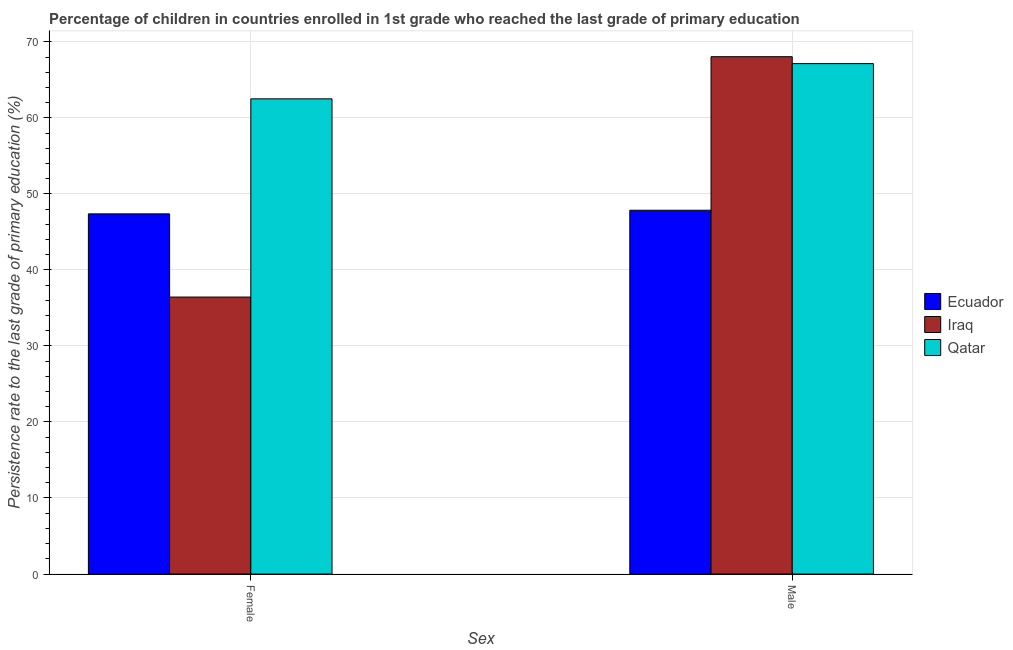How many groups of bars are there?
Give a very brief answer. 2. Are the number of bars per tick equal to the number of legend labels?
Provide a short and direct response. Yes. How many bars are there on the 2nd tick from the left?
Ensure brevity in your answer.  3. How many bars are there on the 2nd tick from the right?
Provide a succinct answer. 3. What is the label of the 1st group of bars from the left?
Offer a terse response. Female. What is the persistence rate of female students in Iraq?
Offer a very short reply. 36.43. Across all countries, what is the maximum persistence rate of female students?
Ensure brevity in your answer.  62.51. Across all countries, what is the minimum persistence rate of female students?
Offer a very short reply. 36.43. In which country was the persistence rate of male students maximum?
Your answer should be compact. Iraq. In which country was the persistence rate of male students minimum?
Offer a terse response. Ecuador. What is the total persistence rate of male students in the graph?
Ensure brevity in your answer.  183.04. What is the difference between the persistence rate of female students in Iraq and that in Qatar?
Make the answer very short. -26.07. What is the difference between the persistence rate of female students in Ecuador and the persistence rate of male students in Iraq?
Ensure brevity in your answer.  -20.68. What is the average persistence rate of female students per country?
Your response must be concise. 48.77. What is the difference between the persistence rate of male students and persistence rate of female students in Qatar?
Your answer should be compact. 4.63. In how many countries, is the persistence rate of male students greater than 24 %?
Provide a short and direct response. 3. What is the ratio of the persistence rate of female students in Qatar to that in Ecuador?
Ensure brevity in your answer.  1.32. Is the persistence rate of female students in Qatar less than that in Iraq?
Your answer should be very brief. No. In how many countries, is the persistence rate of male students greater than the average persistence rate of male students taken over all countries?
Offer a terse response. 2. What does the 2nd bar from the left in Female represents?
Give a very brief answer. Iraq. What does the 2nd bar from the right in Male represents?
Your answer should be very brief. Iraq. How many countries are there in the graph?
Your response must be concise. 3. Does the graph contain any zero values?
Keep it short and to the point. No. Does the graph contain grids?
Your answer should be compact. Yes. Where does the legend appear in the graph?
Provide a succinct answer. Center right. What is the title of the graph?
Offer a very short reply. Percentage of children in countries enrolled in 1st grade who reached the last grade of primary education. Does "Qatar" appear as one of the legend labels in the graph?
Offer a terse response. Yes. What is the label or title of the X-axis?
Your answer should be compact. Sex. What is the label or title of the Y-axis?
Provide a short and direct response. Persistence rate to the last grade of primary education (%). What is the Persistence rate to the last grade of primary education (%) in Ecuador in Female?
Give a very brief answer. 47.37. What is the Persistence rate to the last grade of primary education (%) of Iraq in Female?
Your answer should be compact. 36.43. What is the Persistence rate to the last grade of primary education (%) of Qatar in Female?
Your response must be concise. 62.51. What is the Persistence rate to the last grade of primary education (%) in Ecuador in Male?
Your answer should be very brief. 47.85. What is the Persistence rate to the last grade of primary education (%) in Iraq in Male?
Make the answer very short. 68.05. What is the Persistence rate to the last grade of primary education (%) of Qatar in Male?
Your response must be concise. 67.14. Across all Sex, what is the maximum Persistence rate to the last grade of primary education (%) in Ecuador?
Your response must be concise. 47.85. Across all Sex, what is the maximum Persistence rate to the last grade of primary education (%) of Iraq?
Your answer should be compact. 68.05. Across all Sex, what is the maximum Persistence rate to the last grade of primary education (%) of Qatar?
Your response must be concise. 67.14. Across all Sex, what is the minimum Persistence rate to the last grade of primary education (%) of Ecuador?
Your response must be concise. 47.37. Across all Sex, what is the minimum Persistence rate to the last grade of primary education (%) in Iraq?
Ensure brevity in your answer.  36.43. Across all Sex, what is the minimum Persistence rate to the last grade of primary education (%) of Qatar?
Your response must be concise. 62.51. What is the total Persistence rate to the last grade of primary education (%) in Ecuador in the graph?
Provide a short and direct response. 95.23. What is the total Persistence rate to the last grade of primary education (%) of Iraq in the graph?
Keep it short and to the point. 104.48. What is the total Persistence rate to the last grade of primary education (%) in Qatar in the graph?
Provide a succinct answer. 129.65. What is the difference between the Persistence rate to the last grade of primary education (%) in Ecuador in Female and that in Male?
Ensure brevity in your answer.  -0.48. What is the difference between the Persistence rate to the last grade of primary education (%) of Iraq in Female and that in Male?
Ensure brevity in your answer.  -31.62. What is the difference between the Persistence rate to the last grade of primary education (%) in Qatar in Female and that in Male?
Your answer should be compact. -4.63. What is the difference between the Persistence rate to the last grade of primary education (%) of Ecuador in Female and the Persistence rate to the last grade of primary education (%) of Iraq in Male?
Your answer should be very brief. -20.68. What is the difference between the Persistence rate to the last grade of primary education (%) in Ecuador in Female and the Persistence rate to the last grade of primary education (%) in Qatar in Male?
Make the answer very short. -19.76. What is the difference between the Persistence rate to the last grade of primary education (%) in Iraq in Female and the Persistence rate to the last grade of primary education (%) in Qatar in Male?
Your response must be concise. -30.71. What is the average Persistence rate to the last grade of primary education (%) of Ecuador per Sex?
Make the answer very short. 47.61. What is the average Persistence rate to the last grade of primary education (%) in Iraq per Sex?
Offer a terse response. 52.24. What is the average Persistence rate to the last grade of primary education (%) in Qatar per Sex?
Ensure brevity in your answer.  64.82. What is the difference between the Persistence rate to the last grade of primary education (%) in Ecuador and Persistence rate to the last grade of primary education (%) in Iraq in Female?
Provide a short and direct response. 10.94. What is the difference between the Persistence rate to the last grade of primary education (%) of Ecuador and Persistence rate to the last grade of primary education (%) of Qatar in Female?
Give a very brief answer. -15.13. What is the difference between the Persistence rate to the last grade of primary education (%) of Iraq and Persistence rate to the last grade of primary education (%) of Qatar in Female?
Ensure brevity in your answer.  -26.07. What is the difference between the Persistence rate to the last grade of primary education (%) in Ecuador and Persistence rate to the last grade of primary education (%) in Iraq in Male?
Provide a short and direct response. -20.2. What is the difference between the Persistence rate to the last grade of primary education (%) of Ecuador and Persistence rate to the last grade of primary education (%) of Qatar in Male?
Your response must be concise. -19.29. What is the difference between the Persistence rate to the last grade of primary education (%) of Iraq and Persistence rate to the last grade of primary education (%) of Qatar in Male?
Give a very brief answer. 0.91. What is the ratio of the Persistence rate to the last grade of primary education (%) in Iraq in Female to that in Male?
Your answer should be compact. 0.54. What is the ratio of the Persistence rate to the last grade of primary education (%) of Qatar in Female to that in Male?
Keep it short and to the point. 0.93. What is the difference between the highest and the second highest Persistence rate to the last grade of primary education (%) in Ecuador?
Provide a short and direct response. 0.48. What is the difference between the highest and the second highest Persistence rate to the last grade of primary education (%) in Iraq?
Give a very brief answer. 31.62. What is the difference between the highest and the second highest Persistence rate to the last grade of primary education (%) of Qatar?
Provide a short and direct response. 4.63. What is the difference between the highest and the lowest Persistence rate to the last grade of primary education (%) in Ecuador?
Provide a succinct answer. 0.48. What is the difference between the highest and the lowest Persistence rate to the last grade of primary education (%) in Iraq?
Make the answer very short. 31.62. What is the difference between the highest and the lowest Persistence rate to the last grade of primary education (%) in Qatar?
Offer a very short reply. 4.63. 